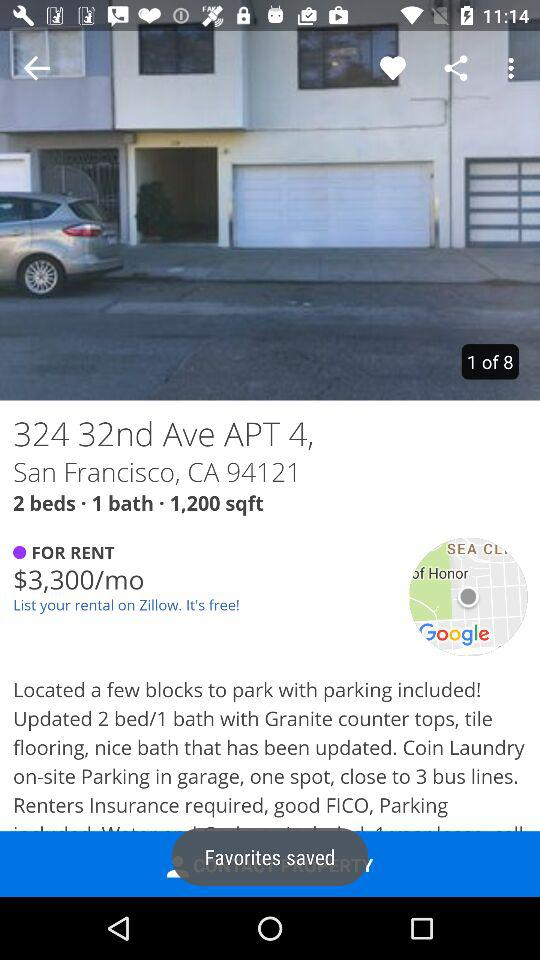How many bedrooms does the rental have?
Answer the question using a single word or phrase. 2 